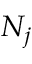Convert formula to latex. <formula><loc_0><loc_0><loc_500><loc_500>N _ { j }</formula> 